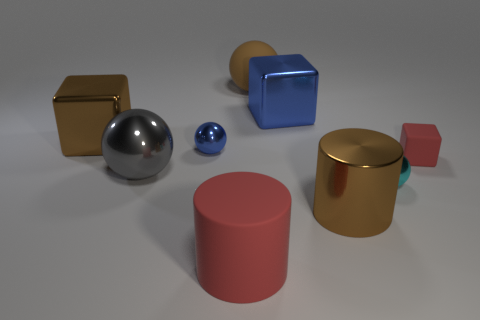What shape is the object that is left of the small cyan metallic object and on the right side of the blue metal block?
Make the answer very short. Cylinder. How many big objects have the same material as the red cylinder?
Your answer should be compact. 1. There is a big shiny thing in front of the large gray sphere; what number of small things are to the left of it?
Provide a succinct answer. 1. What is the shape of the big brown shiny thing that is to the right of the large red rubber object on the left side of the brown ball left of the large brown shiny cylinder?
Your answer should be very brief. Cylinder. The cube that is the same color as the metal cylinder is what size?
Make the answer very short. Large. How many things are either red cubes or small brown matte blocks?
Your answer should be very brief. 1. What is the color of the matte object that is the same size as the cyan shiny thing?
Make the answer very short. Red. Does the big gray object have the same shape as the blue metal object behind the small blue ball?
Make the answer very short. No. What number of things are either brown objects to the left of the large brown cylinder or blocks that are to the left of the big gray object?
Keep it short and to the point. 2. There is a shiny object that is the same color as the shiny cylinder; what is its shape?
Make the answer very short. Cube. 